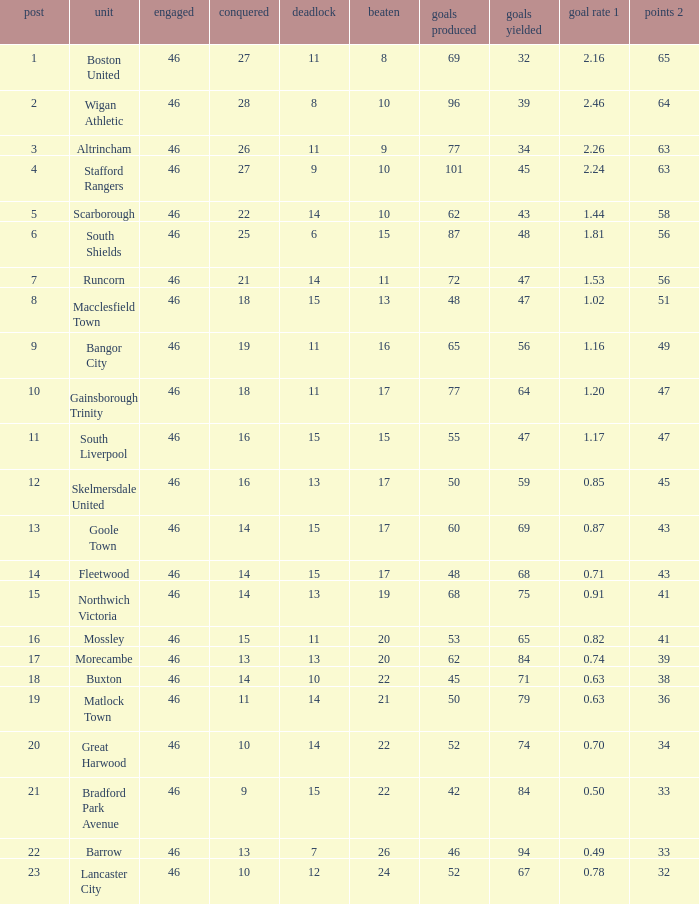Could you help me parse every detail presented in this table? {'header': ['post', 'unit', 'engaged', 'conquered', 'deadlock', 'beaten', 'goals produced', 'goals yielded', 'goal rate 1', 'points 2'], 'rows': [['1', 'Boston United', '46', '27', '11', '8', '69', '32', '2.16', '65'], ['2', 'Wigan Athletic', '46', '28', '8', '10', '96', '39', '2.46', '64'], ['3', 'Altrincham', '46', '26', '11', '9', '77', '34', '2.26', '63'], ['4', 'Stafford Rangers', '46', '27', '9', '10', '101', '45', '2.24', '63'], ['5', 'Scarborough', '46', '22', '14', '10', '62', '43', '1.44', '58'], ['6', 'South Shields', '46', '25', '6', '15', '87', '48', '1.81', '56'], ['7', 'Runcorn', '46', '21', '14', '11', '72', '47', '1.53', '56'], ['8', 'Macclesfield Town', '46', '18', '15', '13', '48', '47', '1.02', '51'], ['9', 'Bangor City', '46', '19', '11', '16', '65', '56', '1.16', '49'], ['10', 'Gainsborough Trinity', '46', '18', '11', '17', '77', '64', '1.20', '47'], ['11', 'South Liverpool', '46', '16', '15', '15', '55', '47', '1.17', '47'], ['12', 'Skelmersdale United', '46', '16', '13', '17', '50', '59', '0.85', '45'], ['13', 'Goole Town', '46', '14', '15', '17', '60', '69', '0.87', '43'], ['14', 'Fleetwood', '46', '14', '15', '17', '48', '68', '0.71', '43'], ['15', 'Northwich Victoria', '46', '14', '13', '19', '68', '75', '0.91', '41'], ['16', 'Mossley', '46', '15', '11', '20', '53', '65', '0.82', '41'], ['17', 'Morecambe', '46', '13', '13', '20', '62', '84', '0.74', '39'], ['18', 'Buxton', '46', '14', '10', '22', '45', '71', '0.63', '38'], ['19', 'Matlock Town', '46', '11', '14', '21', '50', '79', '0.63', '36'], ['20', 'Great Harwood', '46', '10', '14', '22', '52', '74', '0.70', '34'], ['21', 'Bradford Park Avenue', '46', '9', '15', '22', '42', '84', '0.50', '33'], ['22', 'Barrow', '46', '13', '7', '26', '46', '94', '0.49', '33'], ['23', 'Lancaster City', '46', '10', '12', '24', '52', '67', '0.78', '32']]} How many points did Goole Town accumulate? 1.0. 